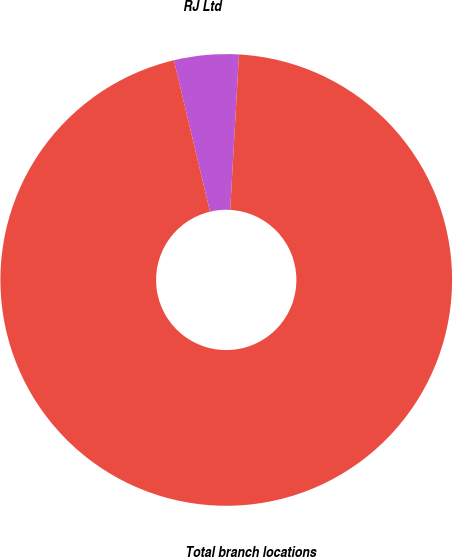Convert chart to OTSL. <chart><loc_0><loc_0><loc_500><loc_500><pie_chart><fcel>RJ Ltd<fcel>Total branch locations<nl><fcel>4.62%<fcel>95.38%<nl></chart> 